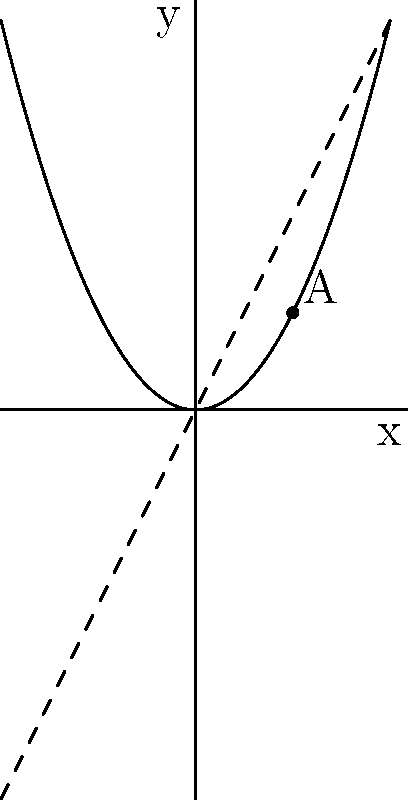As a parent helping your child understand calculus concepts, consider the graph of $f(x)=x^2$ shown above. Point A is at (1,1) on the curve. The dashed line represents the derivative at that point. How would you explain to your child what the derivative means at point A in terms of the school's growth? To explain the meaning of the derivative at point A to your child, follow these steps:

1. Understand that the derivative represents the rate of change or slope of the function at a specific point.

2. Observe that the dashed line is tangent to the curve at point A (1,1).

3. The slope of this tangent line is the derivative at point A.

4. In this case, the slope of the tangent line (derivative) at x=1 is 2, because $f'(x) = 2x$, so $f'(1) = 2(1) = 2$.

5. Relate this to the school context:
   - Let x represent the number of years since the school opened.
   - Let f(x) represent the number of students enrolled.

6. Explain that the derivative (slope) of 2 at point A means:
   - When the school has been open for 1 year (x=1), there are 1 student enrolled (y=1).
   - At this point, the school's enrollment is growing at a rate of 2 students per year.

7. Emphasize that this rate of change is specific to this moment (after 1 year) and may be different at other points in time.
Answer: The derivative at point A represents the instantaneous rate of change in student enrollment (2 students/year) after the school has been open for 1 year. 